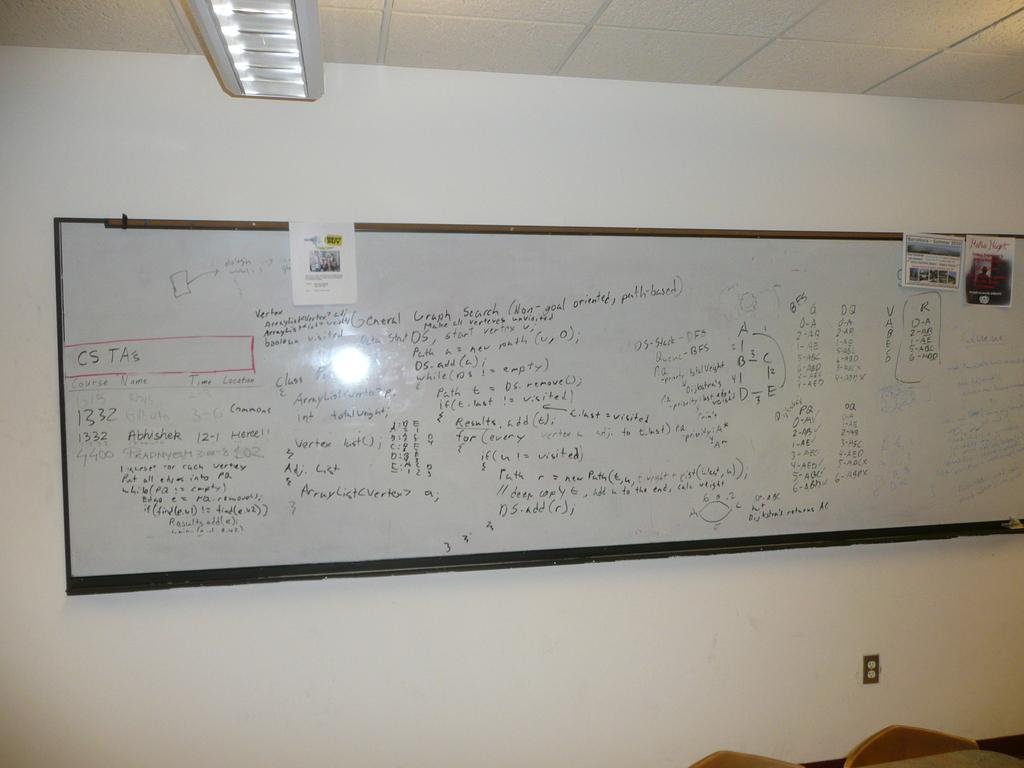What is on the wall in the image? There is a whiteboard on the wall. What is written on the whiteboard? There is writing on the whiteboard. What can be seen in the background of the image? Electric lights, the roof, and chairs are visible in the background. What type of sock is hanging from the word on the whiteboard? There is no sock present in the image, and no word is mentioned in the facts provided. 